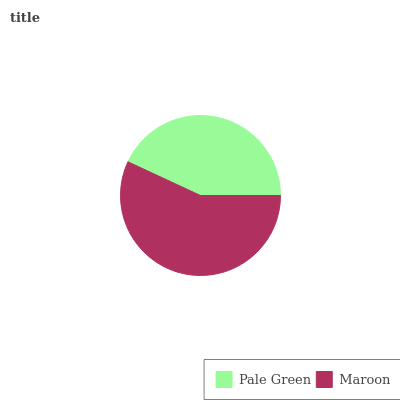Is Pale Green the minimum?
Answer yes or no. Yes. Is Maroon the maximum?
Answer yes or no. Yes. Is Maroon the minimum?
Answer yes or no. No. Is Maroon greater than Pale Green?
Answer yes or no. Yes. Is Pale Green less than Maroon?
Answer yes or no. Yes. Is Pale Green greater than Maroon?
Answer yes or no. No. Is Maroon less than Pale Green?
Answer yes or no. No. Is Maroon the high median?
Answer yes or no. Yes. Is Pale Green the low median?
Answer yes or no. Yes. Is Pale Green the high median?
Answer yes or no. No. Is Maroon the low median?
Answer yes or no. No. 